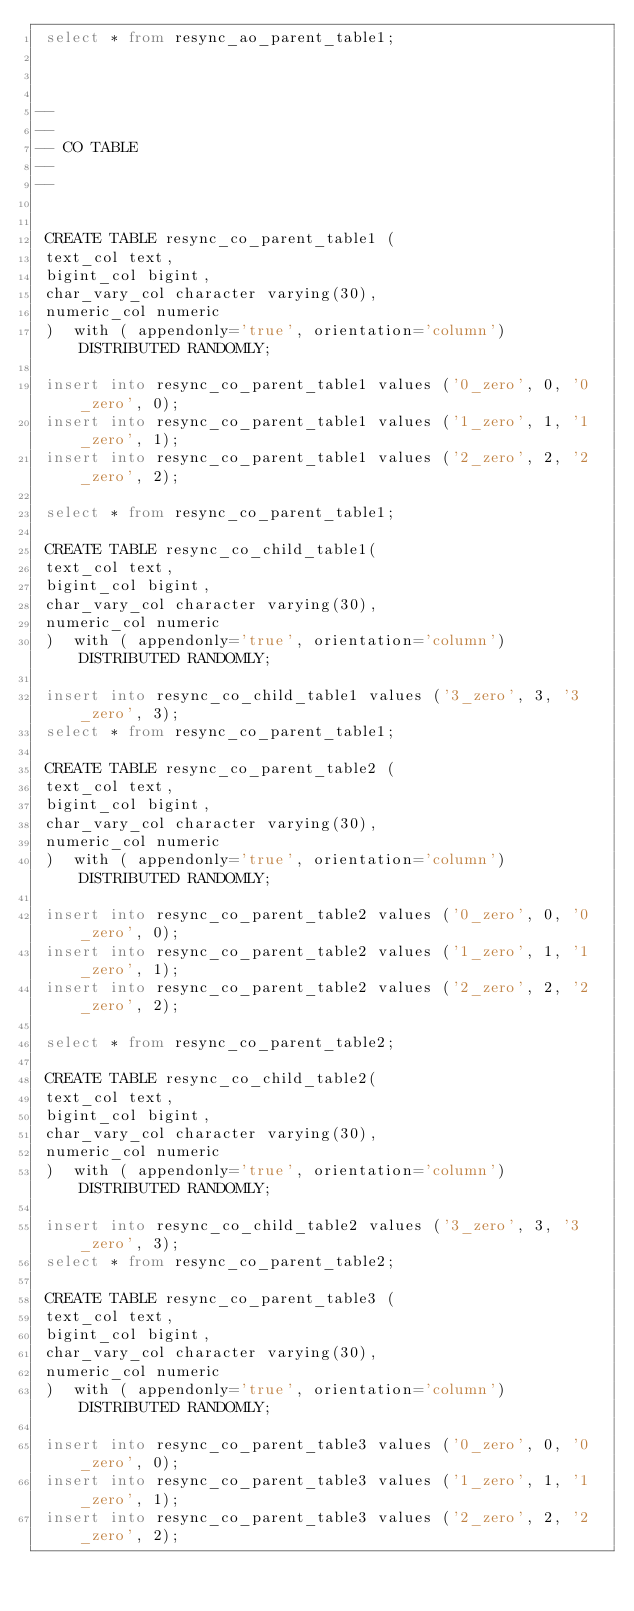Convert code to text. <code><loc_0><loc_0><loc_500><loc_500><_SQL_> select * from resync_ao_parent_table1;



--
--
-- CO TABLE
--
--


 CREATE TABLE resync_co_parent_table1 (
 text_col text,
 bigint_col bigint,
 char_vary_col character varying(30),
 numeric_col numeric
 )  with ( appendonly='true', orientation='column')  DISTRIBUTED RANDOMLY;

 insert into resync_co_parent_table1 values ('0_zero', 0, '0_zero', 0);
 insert into resync_co_parent_table1 values ('1_zero', 1, '1_zero', 1);
 insert into resync_co_parent_table1 values ('2_zero', 2, '2_zero', 2);

 select * from resync_co_parent_table1;

 CREATE TABLE resync_co_child_table1(
 text_col text,
 bigint_col bigint,
 char_vary_col character varying(30),
 numeric_col numeric
 )  with ( appendonly='true', orientation='column')  DISTRIBUTED RANDOMLY;

 insert into resync_co_child_table1 values ('3_zero', 3, '3_zero', 3);
 select * from resync_co_parent_table1;

 CREATE TABLE resync_co_parent_table2 (
 text_col text,
 bigint_col bigint,
 char_vary_col character varying(30),
 numeric_col numeric
 )  with ( appendonly='true', orientation='column')  DISTRIBUTED RANDOMLY;

 insert into resync_co_parent_table2 values ('0_zero', 0, '0_zero', 0);
 insert into resync_co_parent_table2 values ('1_zero', 1, '1_zero', 1);
 insert into resync_co_parent_table2 values ('2_zero', 2, '2_zero', 2);

 select * from resync_co_parent_table2;

 CREATE TABLE resync_co_child_table2(
 text_col text,
 bigint_col bigint,
 char_vary_col character varying(30),
 numeric_col numeric
 )  with ( appendonly='true', orientation='column')  DISTRIBUTED RANDOMLY;

 insert into resync_co_child_table2 values ('3_zero', 3, '3_zero', 3);
 select * from resync_co_parent_table2;

 CREATE TABLE resync_co_parent_table3 (
 text_col text,
 bigint_col bigint,
 char_vary_col character varying(30),
 numeric_col numeric
 )  with ( appendonly='true', orientation='column')  DISTRIBUTED RANDOMLY;

 insert into resync_co_parent_table3 values ('0_zero', 0, '0_zero', 0);
 insert into resync_co_parent_table3 values ('1_zero', 1, '1_zero', 1);
 insert into resync_co_parent_table3 values ('2_zero', 2, '2_zero', 2);
</code> 